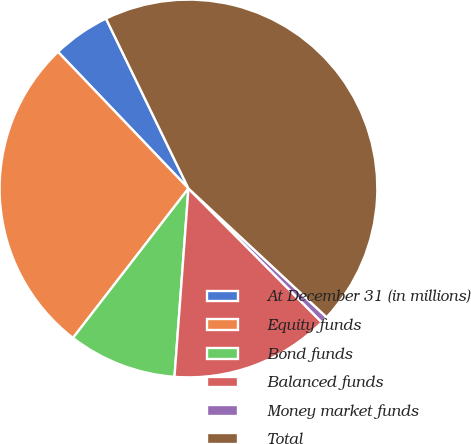Convert chart. <chart><loc_0><loc_0><loc_500><loc_500><pie_chart><fcel>At December 31 (in millions)<fcel>Equity funds<fcel>Bond funds<fcel>Balanced funds<fcel>Money market funds<fcel>Total<nl><fcel>4.94%<fcel>27.4%<fcel>9.29%<fcel>13.65%<fcel>0.59%<fcel>44.13%<nl></chart> 